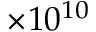<formula> <loc_0><loc_0><loc_500><loc_500>\times 1 0 ^ { 1 0 }</formula> 